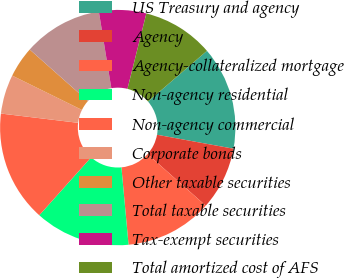<chart> <loc_0><loc_0><loc_500><loc_500><pie_chart><fcel>US Treasury and agency<fcel>Agency<fcel>Agency-collateralized mortgage<fcel>Non-agency residential<fcel>Non-agency commercial<fcel>Corporate bonds<fcel>Other taxable securities<fcel>Total taxable securities<fcel>Tax-exempt securities<fcel>Total amortized cost of AFS<nl><fcel>14.18%<fcel>8.68%<fcel>11.98%<fcel>13.08%<fcel>15.28%<fcel>5.38%<fcel>4.26%<fcel>10.88%<fcel>6.48%<fcel>9.78%<nl></chart> 